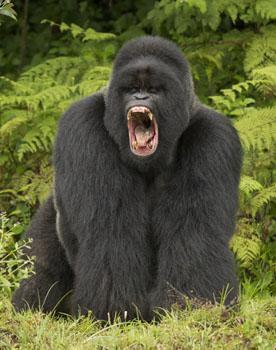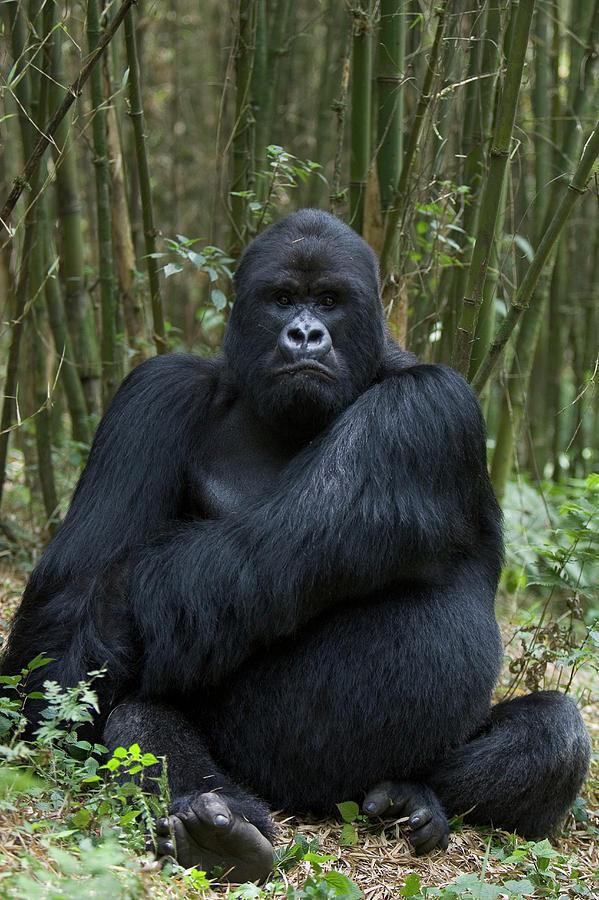The first image is the image on the left, the second image is the image on the right. Considering the images on both sides, is "There are two gorillas in one picture and one in the other." valid? Answer yes or no. No. The first image is the image on the left, the second image is the image on the right. Considering the images on both sides, is "The left image shows one adult gorilla on all fours, and the right image shows one adult gorilla with a frowning face looking directly at the camera." valid? Answer yes or no. Yes. 